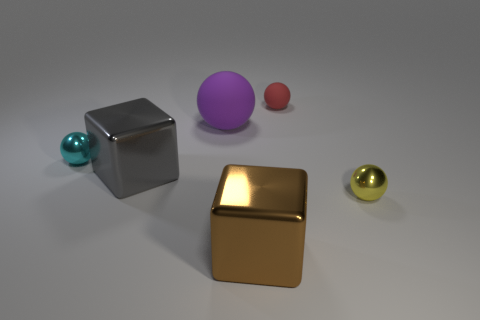Subtract all tiny red balls. How many balls are left? 3 Add 1 tiny brown cubes. How many objects exist? 7 Subtract all balls. How many objects are left? 2 Subtract all brown cubes. How many cubes are left? 1 Subtract 0 red cylinders. How many objects are left? 6 Subtract 2 cubes. How many cubes are left? 0 Subtract all brown balls. Subtract all brown blocks. How many balls are left? 4 Subtract all purple cubes. How many yellow spheres are left? 1 Subtract all yellow balls. Subtract all red rubber objects. How many objects are left? 4 Add 1 large brown metallic blocks. How many large brown metallic blocks are left? 2 